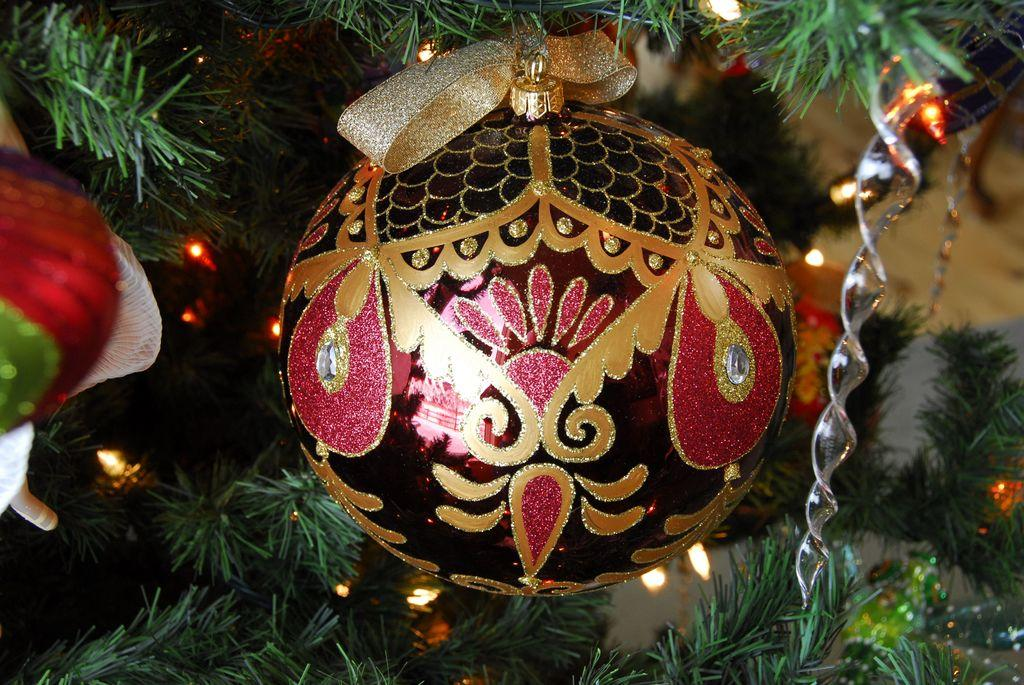What is the main object in the image? There is a tree in the image. What is the color of the tree? The tree is green in color. What else can be seen near the tree? There are lights and decorative items visible near the tree. What story does the ghost tell about the tree in the image? There is no ghost present in the image, and therefore no story can be told about the tree. 